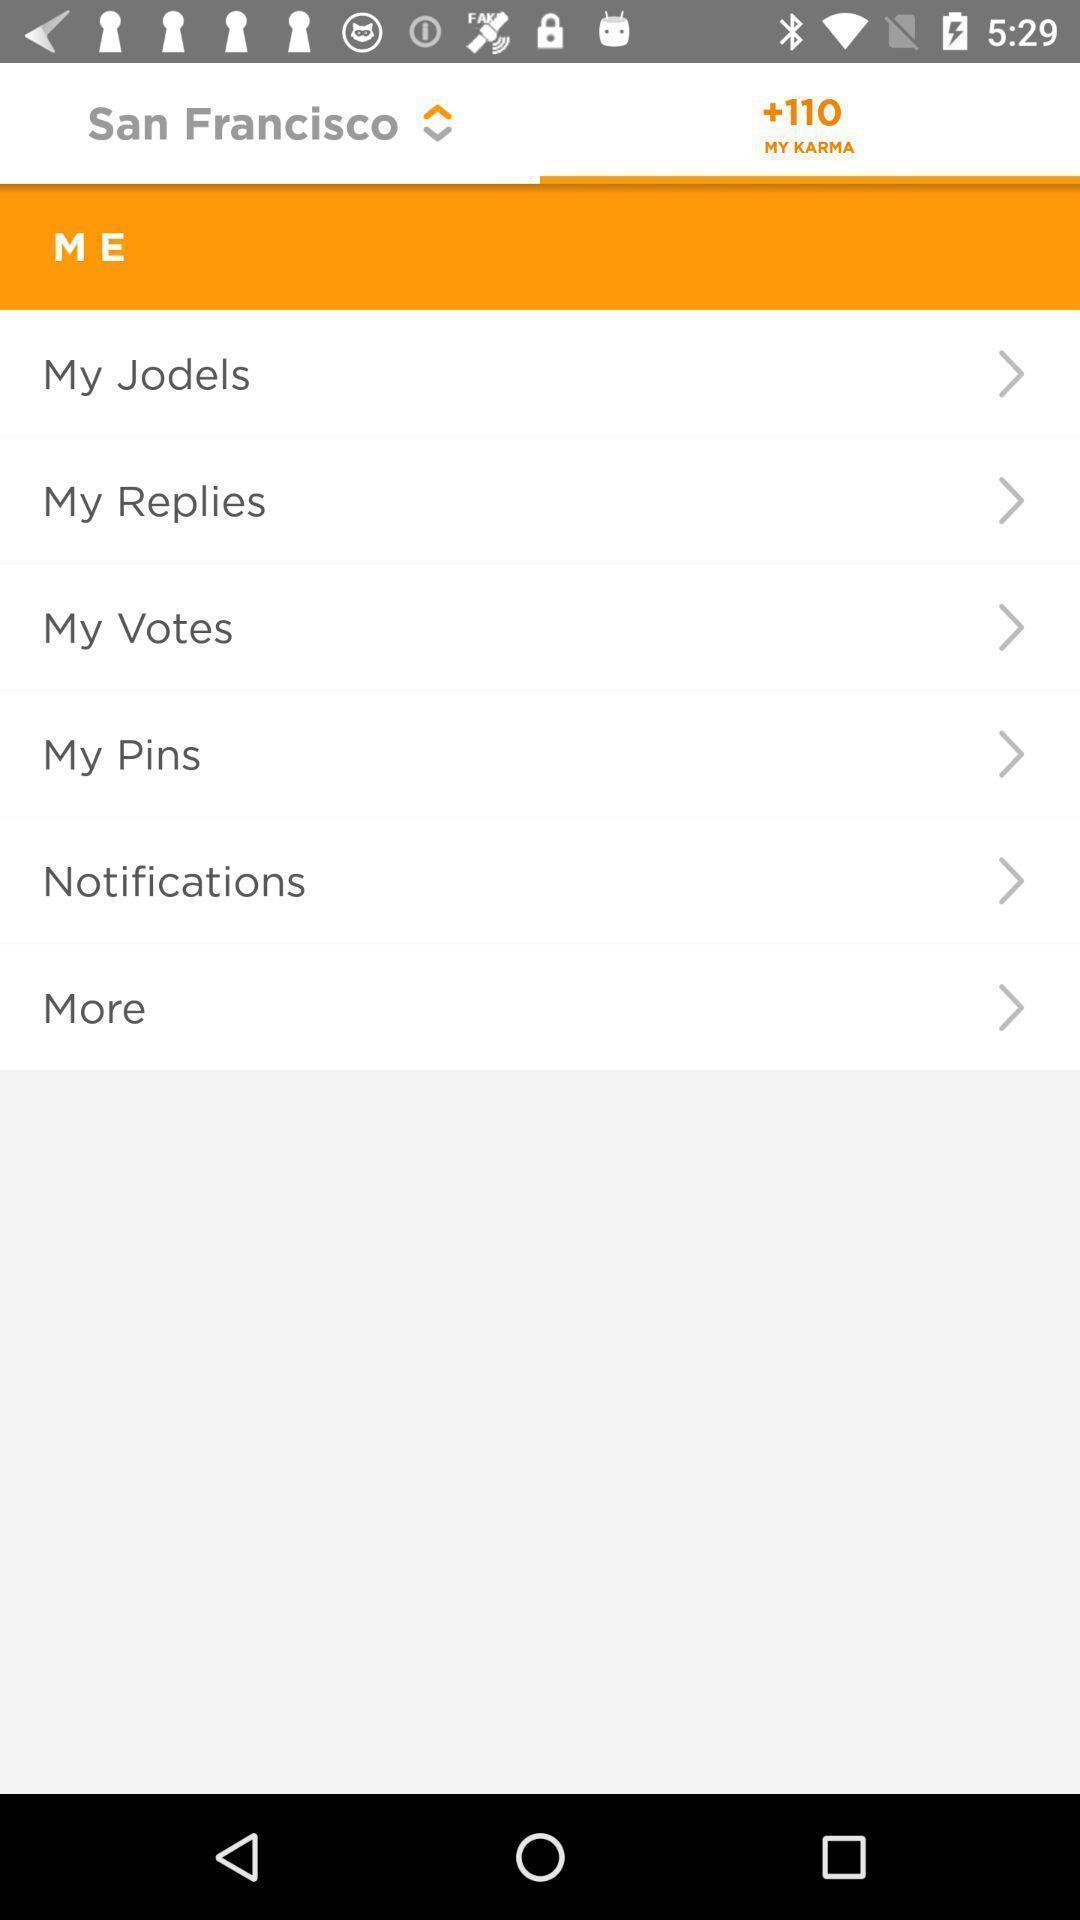What is the overall content of this screenshot? Screen showing menu options in a social media app. 